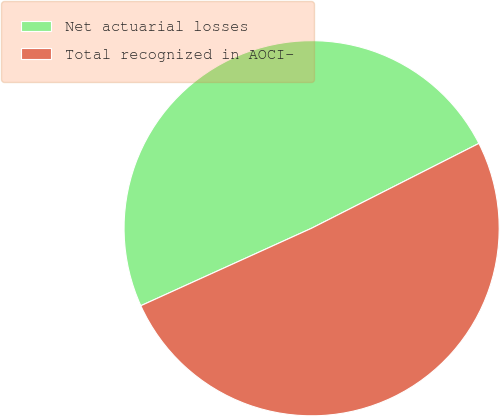Convert chart. <chart><loc_0><loc_0><loc_500><loc_500><pie_chart><fcel>Net actuarial losses<fcel>Total recognized in AOCI-<nl><fcel>49.31%<fcel>50.69%<nl></chart> 